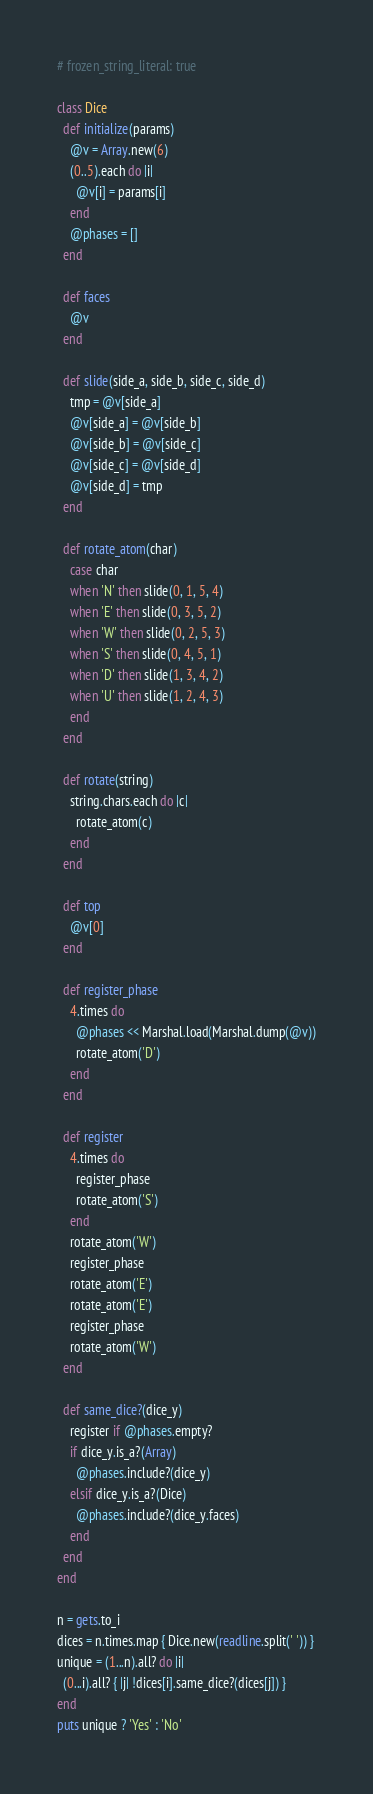Convert code to text. <code><loc_0><loc_0><loc_500><loc_500><_Ruby_># frozen_string_literal: true

class Dice
  def initialize(params)
    @v = Array.new(6)
    (0..5).each do |i|
      @v[i] = params[i]
    end
    @phases = []
  end

  def faces
    @v
  end

  def slide(side_a, side_b, side_c, side_d)
    tmp = @v[side_a]
    @v[side_a] = @v[side_b]
    @v[side_b] = @v[side_c]
    @v[side_c] = @v[side_d]
    @v[side_d] = tmp
  end

  def rotate_atom(char)
    case char
    when 'N' then slide(0, 1, 5, 4)
    when 'E' then slide(0, 3, 5, 2)
    when 'W' then slide(0, 2, 5, 3)
    when 'S' then slide(0, 4, 5, 1)
    when 'D' then slide(1, 3, 4, 2)
    when 'U' then slide(1, 2, 4, 3)
    end
  end

  def rotate(string)
    string.chars.each do |c|
      rotate_atom(c)
    end
  end

  def top
    @v[0]
  end

  def register_phase
    4.times do
      @phases << Marshal.load(Marshal.dump(@v))
      rotate_atom('D')
    end
  end

  def register
    4.times do
      register_phase
      rotate_atom('S')
    end
    rotate_atom('W')
    register_phase
    rotate_atom('E')
    rotate_atom('E')
    register_phase
    rotate_atom('W')
  end

  def same_dice?(dice_y)
    register if @phases.empty?
    if dice_y.is_a?(Array)
      @phases.include?(dice_y)
    elsif dice_y.is_a?(Dice)
      @phases.include?(dice_y.faces)
    end
  end
end

n = gets.to_i
dices = n.times.map { Dice.new(readline.split(' ')) }
unique = (1...n).all? do |i|
  (0...i).all? { |j| !dices[i].same_dice?(dices[j]) }
end
puts unique ? 'Yes' : 'No'

</code> 